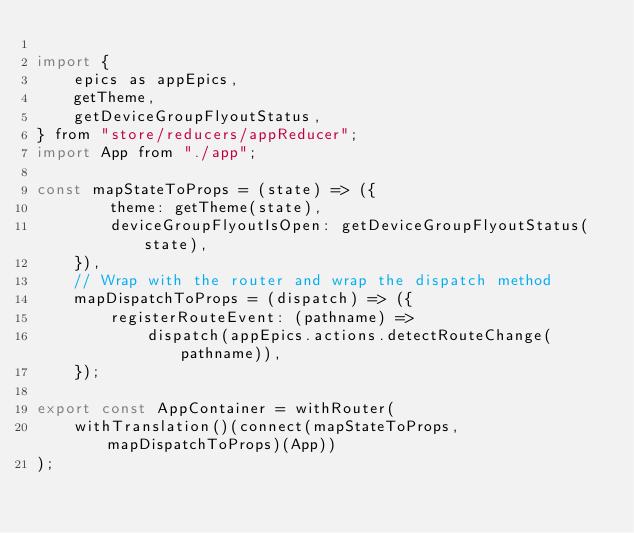<code> <loc_0><loc_0><loc_500><loc_500><_JavaScript_>
import {
    epics as appEpics,
    getTheme,
    getDeviceGroupFlyoutStatus,
} from "store/reducers/appReducer";
import App from "./app";

const mapStateToProps = (state) => ({
        theme: getTheme(state),
        deviceGroupFlyoutIsOpen: getDeviceGroupFlyoutStatus(state),
    }),
    // Wrap with the router and wrap the dispatch method
    mapDispatchToProps = (dispatch) => ({
        registerRouteEvent: (pathname) =>
            dispatch(appEpics.actions.detectRouteChange(pathname)),
    });

export const AppContainer = withRouter(
    withTranslation()(connect(mapStateToProps, mapDispatchToProps)(App))
);
</code> 